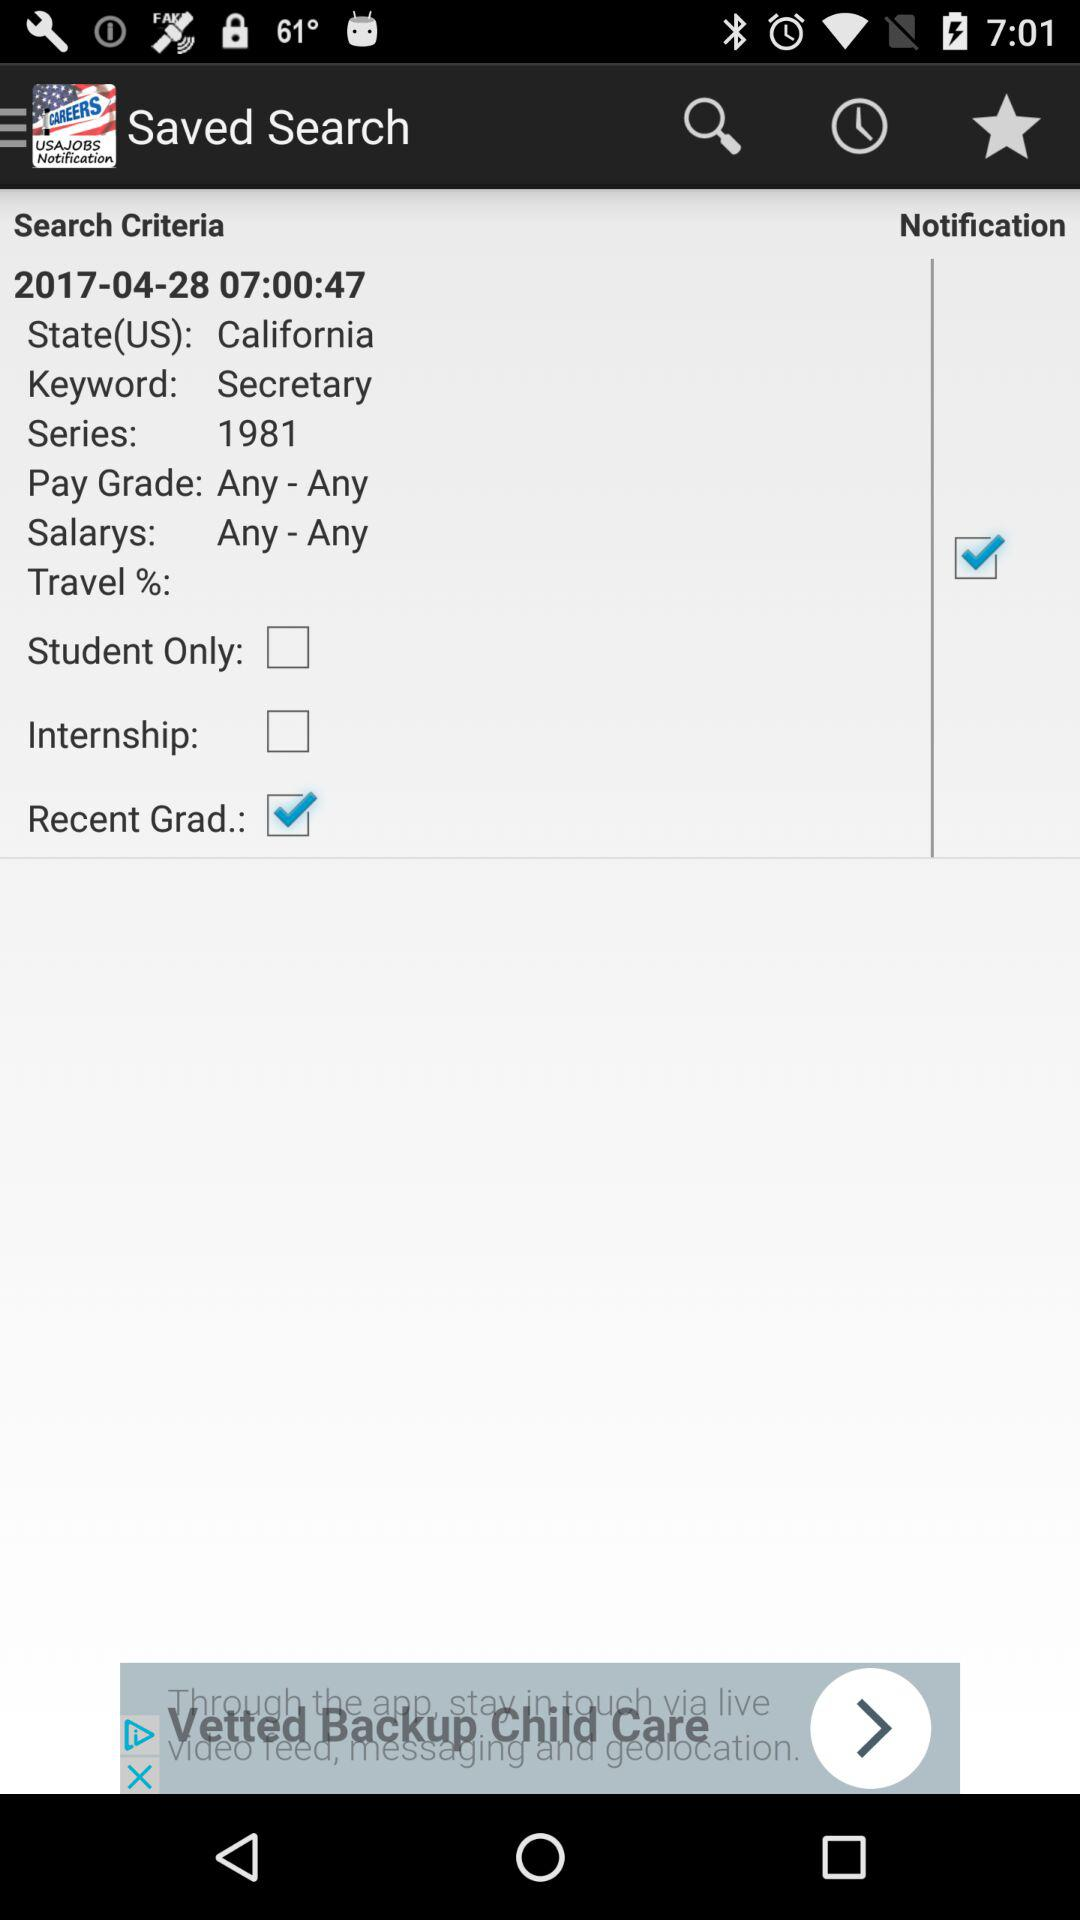What is the current status of the travel?
When the provided information is insufficient, respond with <no answer>. <no answer> 